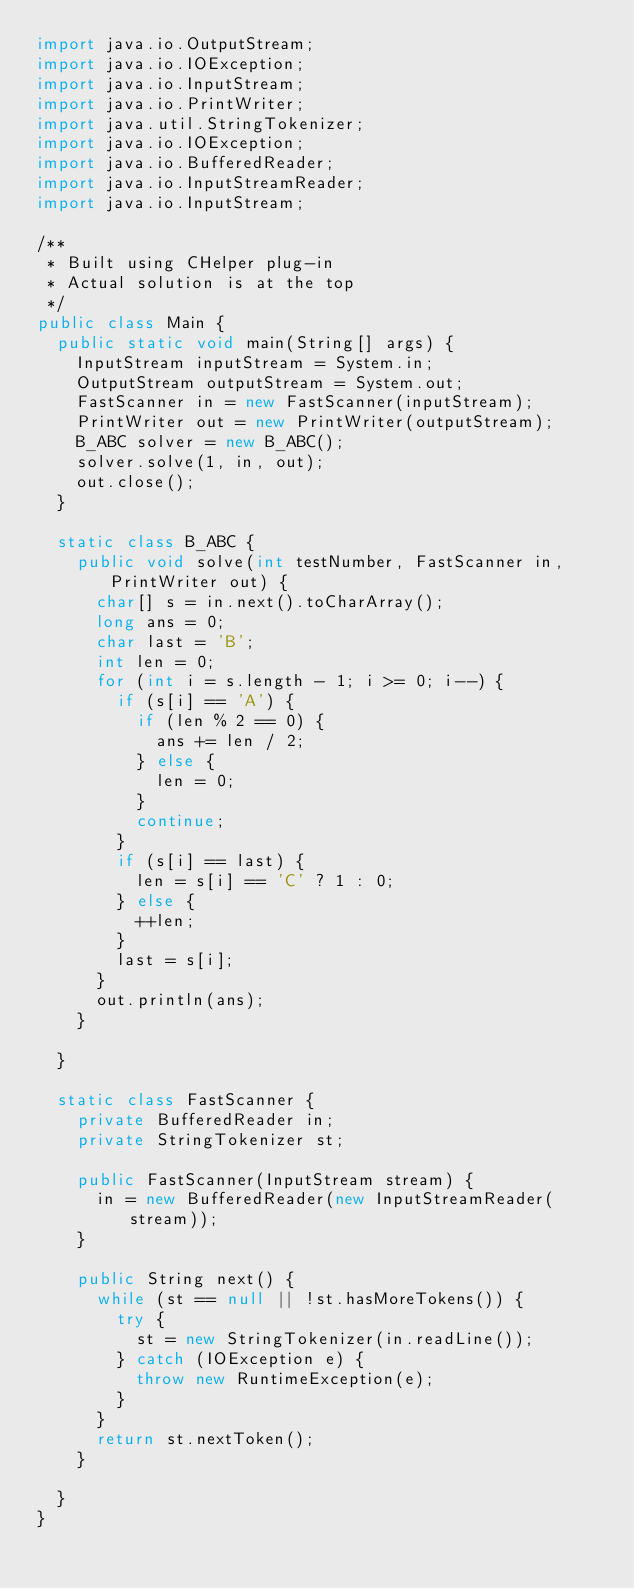<code> <loc_0><loc_0><loc_500><loc_500><_Java_>import java.io.OutputStream;
import java.io.IOException;
import java.io.InputStream;
import java.io.PrintWriter;
import java.util.StringTokenizer;
import java.io.IOException;
import java.io.BufferedReader;
import java.io.InputStreamReader;
import java.io.InputStream;

/**
 * Built using CHelper plug-in
 * Actual solution is at the top
 */
public class Main {
	public static void main(String[] args) {
		InputStream inputStream = System.in;
		OutputStream outputStream = System.out;
		FastScanner in = new FastScanner(inputStream);
		PrintWriter out = new PrintWriter(outputStream);
		B_ABC solver = new B_ABC();
		solver.solve(1, in, out);
		out.close();
	}

	static class B_ABC {
		public void solve(int testNumber, FastScanner in, PrintWriter out) {
			char[] s = in.next().toCharArray();
			long ans = 0;
			char last = 'B';
			int len = 0;
			for (int i = s.length - 1; i >= 0; i--) {
				if (s[i] == 'A') {
					if (len % 2 == 0) {
						ans += len / 2;
					} else {
						len = 0;
					}
					continue;
				}
				if (s[i] == last) {
					len = s[i] == 'C' ? 1 : 0;
				} else {
					++len;
				}
				last = s[i];
			}
			out.println(ans);
		}

	}

	static class FastScanner {
		private BufferedReader in;
		private StringTokenizer st;

		public FastScanner(InputStream stream) {
			in = new BufferedReader(new InputStreamReader(stream));
		}

		public String next() {
			while (st == null || !st.hasMoreTokens()) {
				try {
					st = new StringTokenizer(in.readLine());
				} catch (IOException e) {
					throw new RuntimeException(e);
				}
			}
			return st.nextToken();
		}

	}
}

</code> 